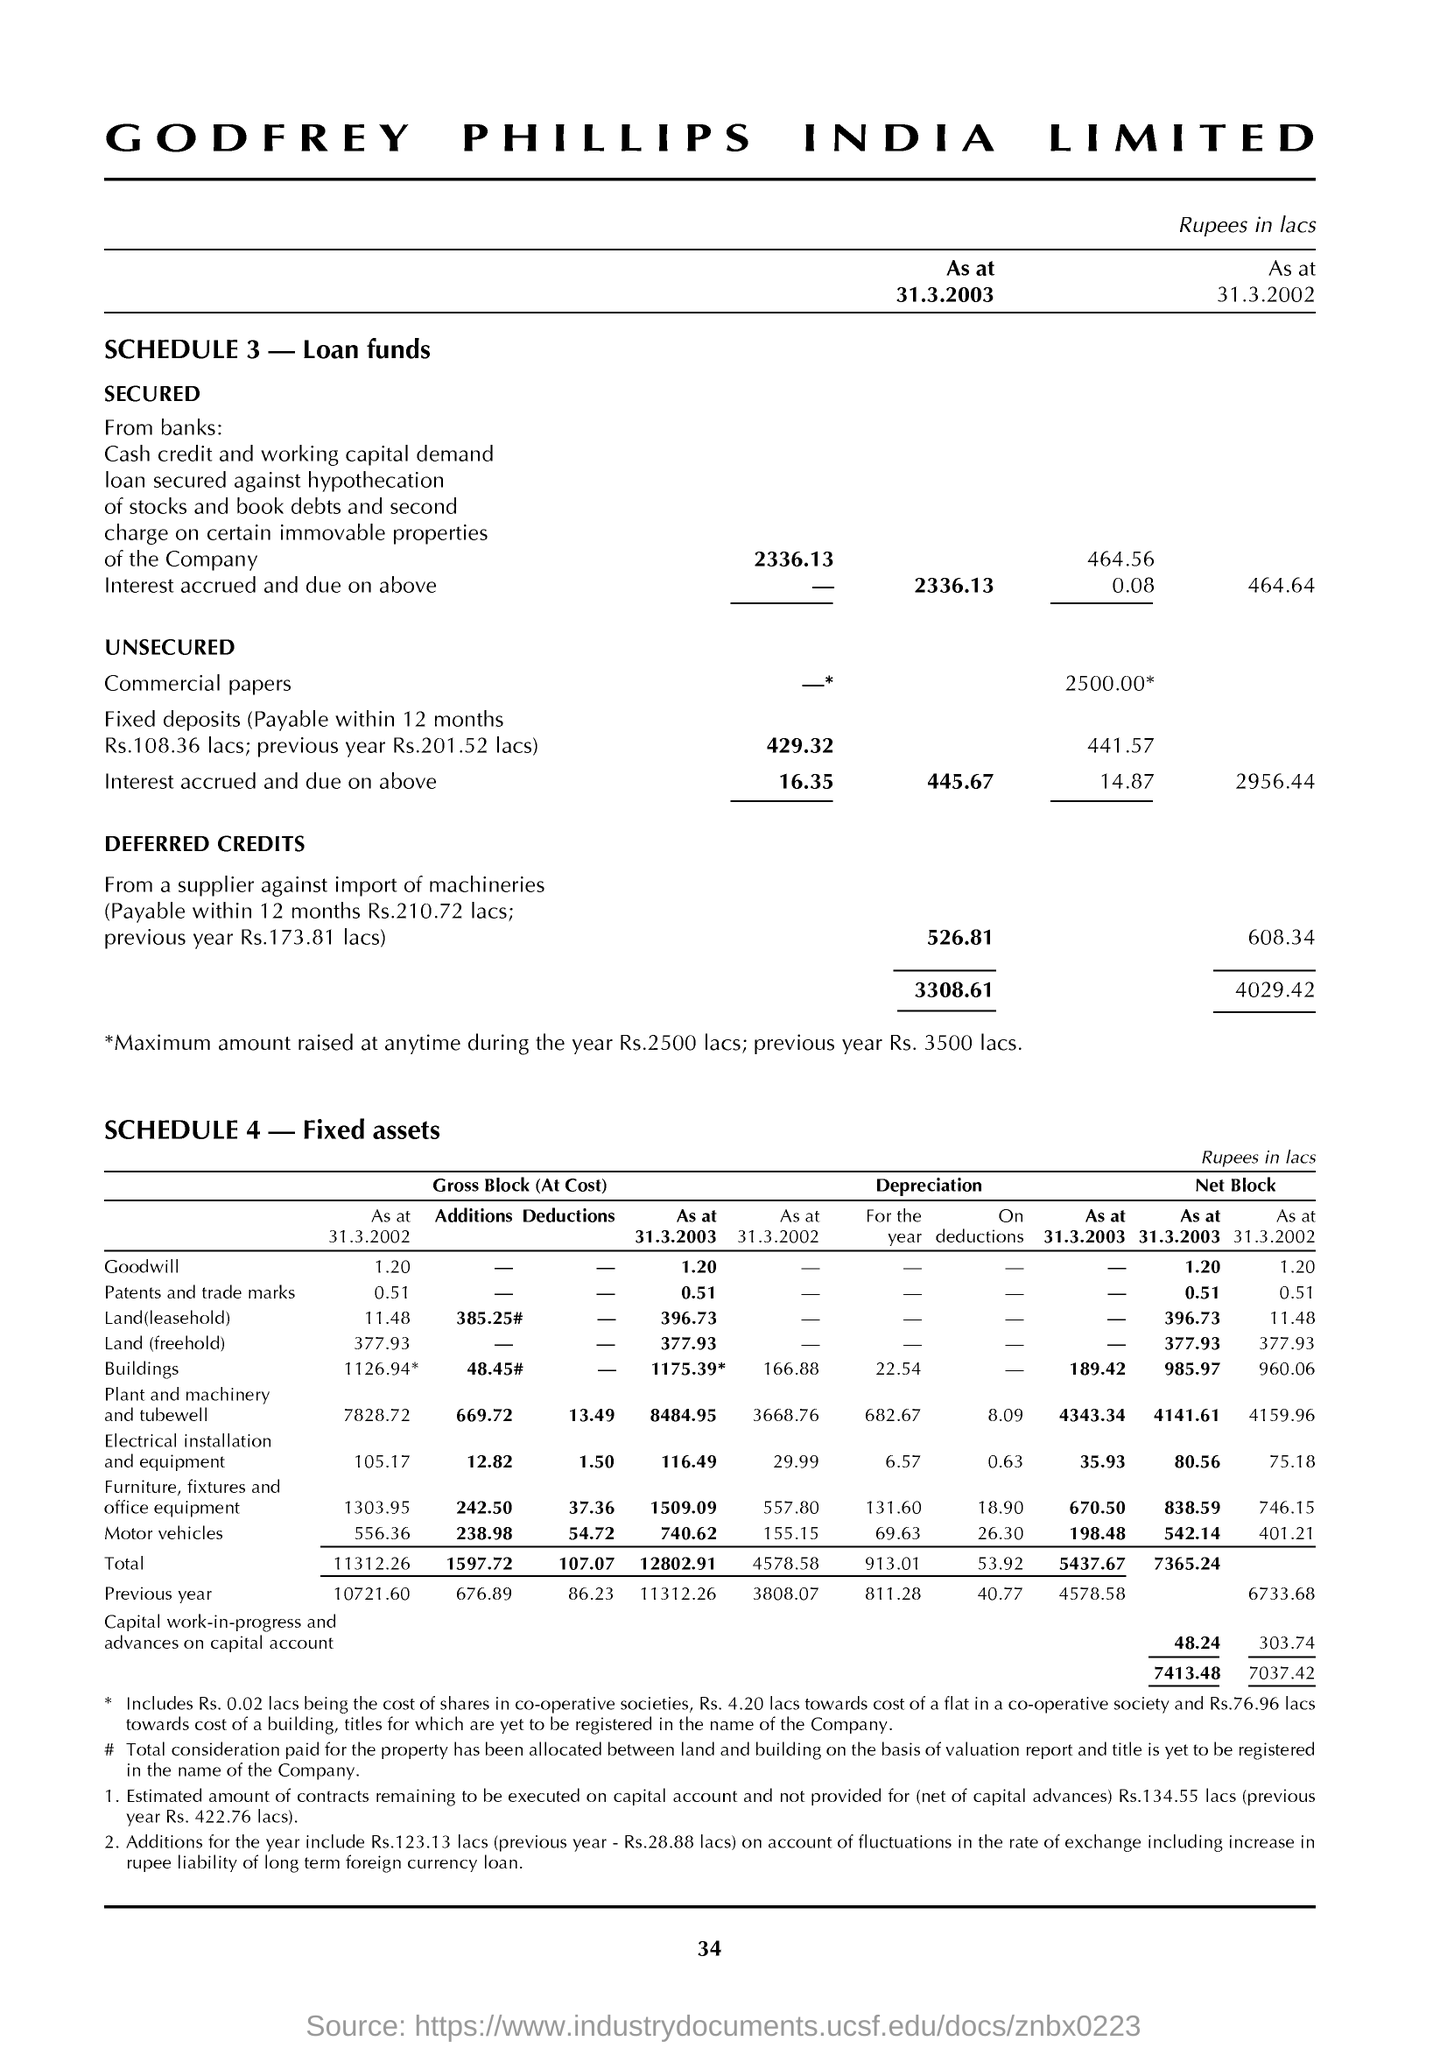Specify some key components in this picture. The letter head indicates that the letter is from "Godfrey Phillips India Limited. What is showing SCHEDULE 3? Loan funds. 